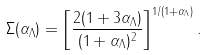Convert formula to latex. <formula><loc_0><loc_0><loc_500><loc_500>\Sigma ( { \alpha _ { \Lambda } } ) = \left [ \frac { 2 ( 1 + 3 { \alpha _ { \Lambda } } ) } { ( 1 + { \alpha _ { \Lambda } } ) ^ { 2 } } \right ] ^ { 1 / ( 1 + { \alpha _ { \Lambda } } ) } .</formula> 